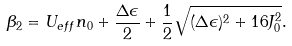Convert formula to latex. <formula><loc_0><loc_0><loc_500><loc_500>\beta _ { 2 } = U _ { e f f } n _ { 0 } + \frac { \Delta \epsilon } { 2 } + \frac { 1 } { 2 } \sqrt { ( \Delta \epsilon ) ^ { 2 } + 1 6 J _ { 0 } ^ { 2 } } .</formula> 